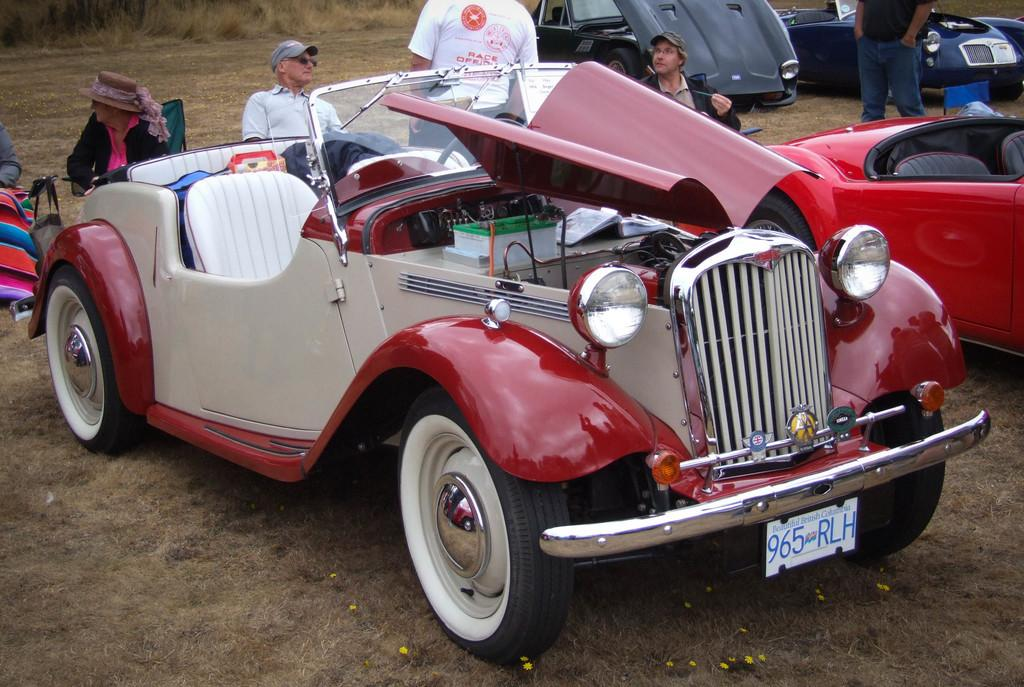What type of environment is shown in the image? The image depicts a dried grassland area. What else can be seen in the image besides the grassland? There are cars and people in the image. Can you describe the people in the image? One person is wearing a hat in the image. What type of cracker is being fed to the animals in the zoo in the image? There is no zoo or animals present in the image, and therefore no crackers being fed to them. Can you tell me how many insects are crawling on the person wearing the hat in the image? There are no insects visible on the person wearing the hat in the image. 